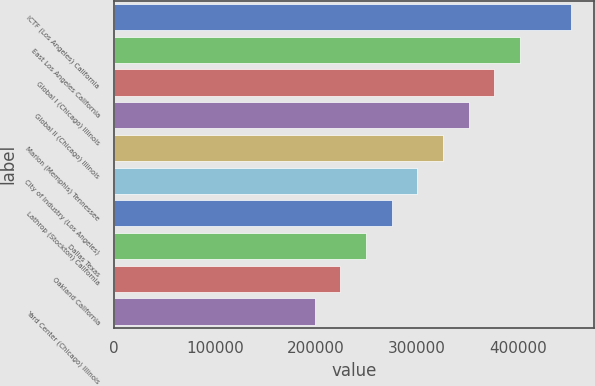<chart> <loc_0><loc_0><loc_500><loc_500><bar_chart><fcel>ICTF (Los Angeles) California<fcel>East Los Angeles California<fcel>Global I (Chicago) Illinois<fcel>Global II (Chicago) Illinois<fcel>Marion (Memphis) Tennessee<fcel>City of Industry (Los Angeles)<fcel>Lathrop (Stockton) California<fcel>Dallas Texas<fcel>Oakland California<fcel>Yard Center (Chicago) Illinois<nl><fcel>453000<fcel>402200<fcel>376800<fcel>351400<fcel>326000<fcel>300600<fcel>275200<fcel>249800<fcel>224400<fcel>199000<nl></chart> 